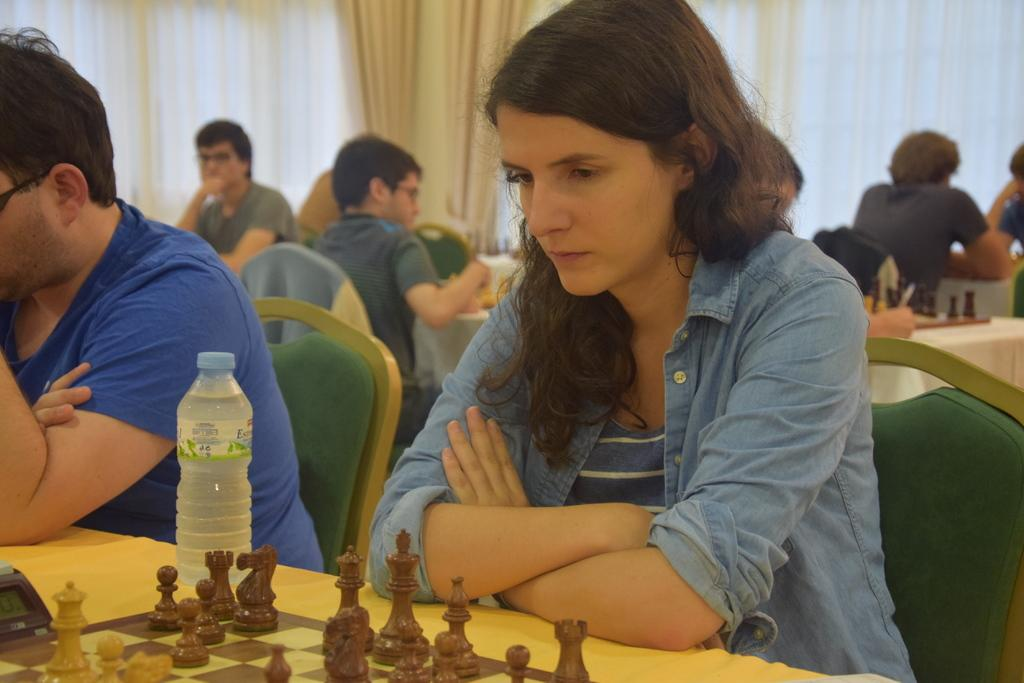What are the persons in the image doing? The persons in the image are sitting on chairs. Where are the chairs located in relation to the table? The chairs are in front of a table. What can be seen on the table? There is at least one chess board and chess pieces on the table. What type of window treatment is visible in the image? There are curtains visible in the image. What is the opinion of the celery on the chess game in the image? There is no celery present in the image, and therefore no opinion can be attributed to it. 